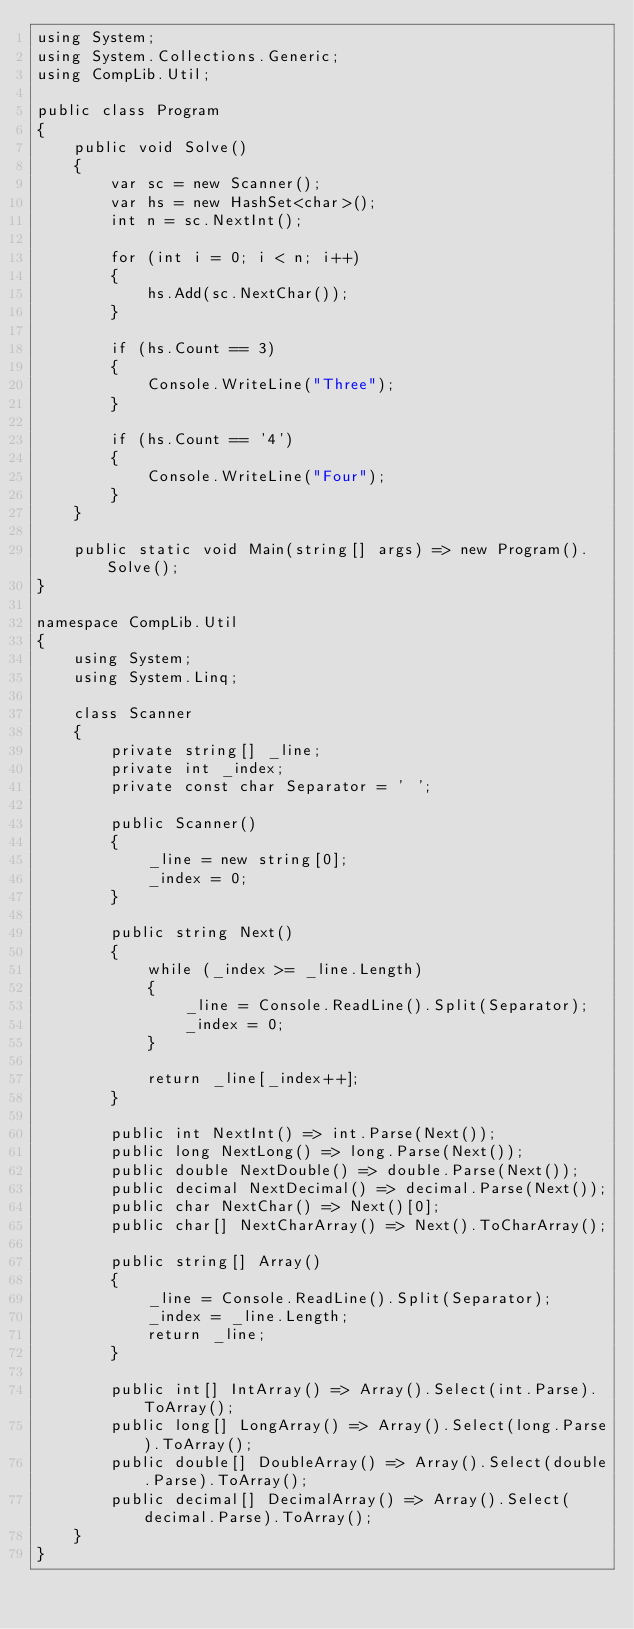Convert code to text. <code><loc_0><loc_0><loc_500><loc_500><_C#_>using System;
using System.Collections.Generic;
using CompLib.Util;

public class Program
{
    public void Solve()
    {
        var sc = new Scanner();
        var hs = new HashSet<char>();
        int n = sc.NextInt();

        for (int i = 0; i < n; i++)
        {
            hs.Add(sc.NextChar());
        }

        if (hs.Count == 3)
        {
            Console.WriteLine("Three");
        }

        if (hs.Count == '4')
        {
            Console.WriteLine("Four");
        }
    }

    public static void Main(string[] args) => new Program().Solve();
}

namespace CompLib.Util
{
    using System;
    using System.Linq;

    class Scanner
    {
        private string[] _line;
        private int _index;
        private const char Separator = ' ';

        public Scanner()
        {
            _line = new string[0];
            _index = 0;
        }

        public string Next()
        {
            while (_index >= _line.Length)
            {
                _line = Console.ReadLine().Split(Separator);
                _index = 0;
            }

            return _line[_index++];
        }

        public int NextInt() => int.Parse(Next());
        public long NextLong() => long.Parse(Next());
        public double NextDouble() => double.Parse(Next());
        public decimal NextDecimal() => decimal.Parse(Next());
        public char NextChar() => Next()[0];
        public char[] NextCharArray() => Next().ToCharArray();

        public string[] Array()
        {
            _line = Console.ReadLine().Split(Separator);
            _index = _line.Length;
            return _line;
        }

        public int[] IntArray() => Array().Select(int.Parse).ToArray();
        public long[] LongArray() => Array().Select(long.Parse).ToArray();
        public double[] DoubleArray() => Array().Select(double.Parse).ToArray();
        public decimal[] DecimalArray() => Array().Select(decimal.Parse).ToArray();
    }
}</code> 